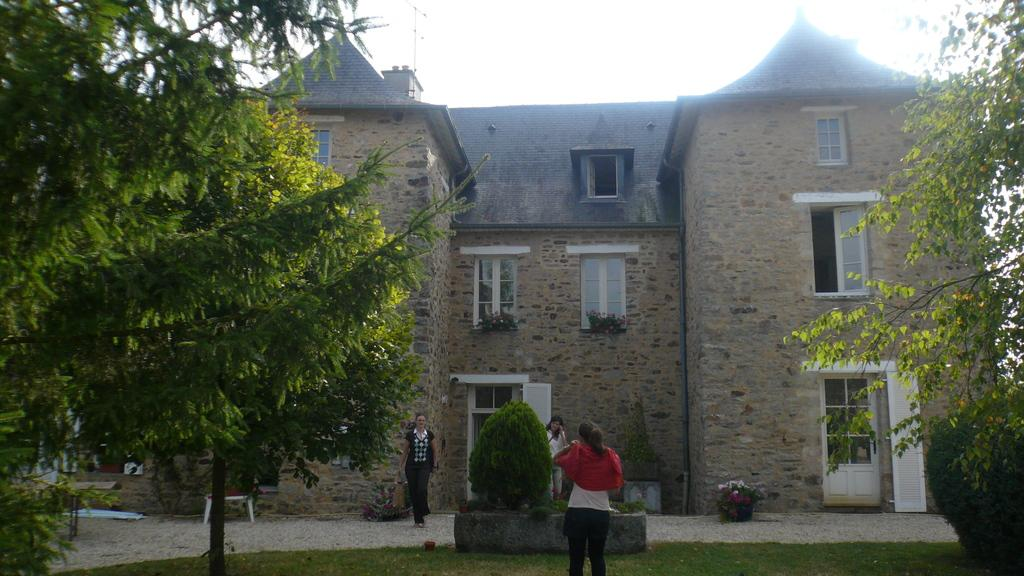What is the main structure in the image? There is a castle in the image. What feature of the castle is mentioned in the facts? The castle has many windows. Who or what can be seen near the castle? There are three ladies standing in front of the castle. What type of vegetation is present in the image? There are trees on either side of the grassland. What part of the natural environment is visible in the image? The sky is visible above the grassland. What color is the chalk used by the ladies to draw on the map in the image? There is no mention of chalk, ladies drawing on a map, or any map in the image. 